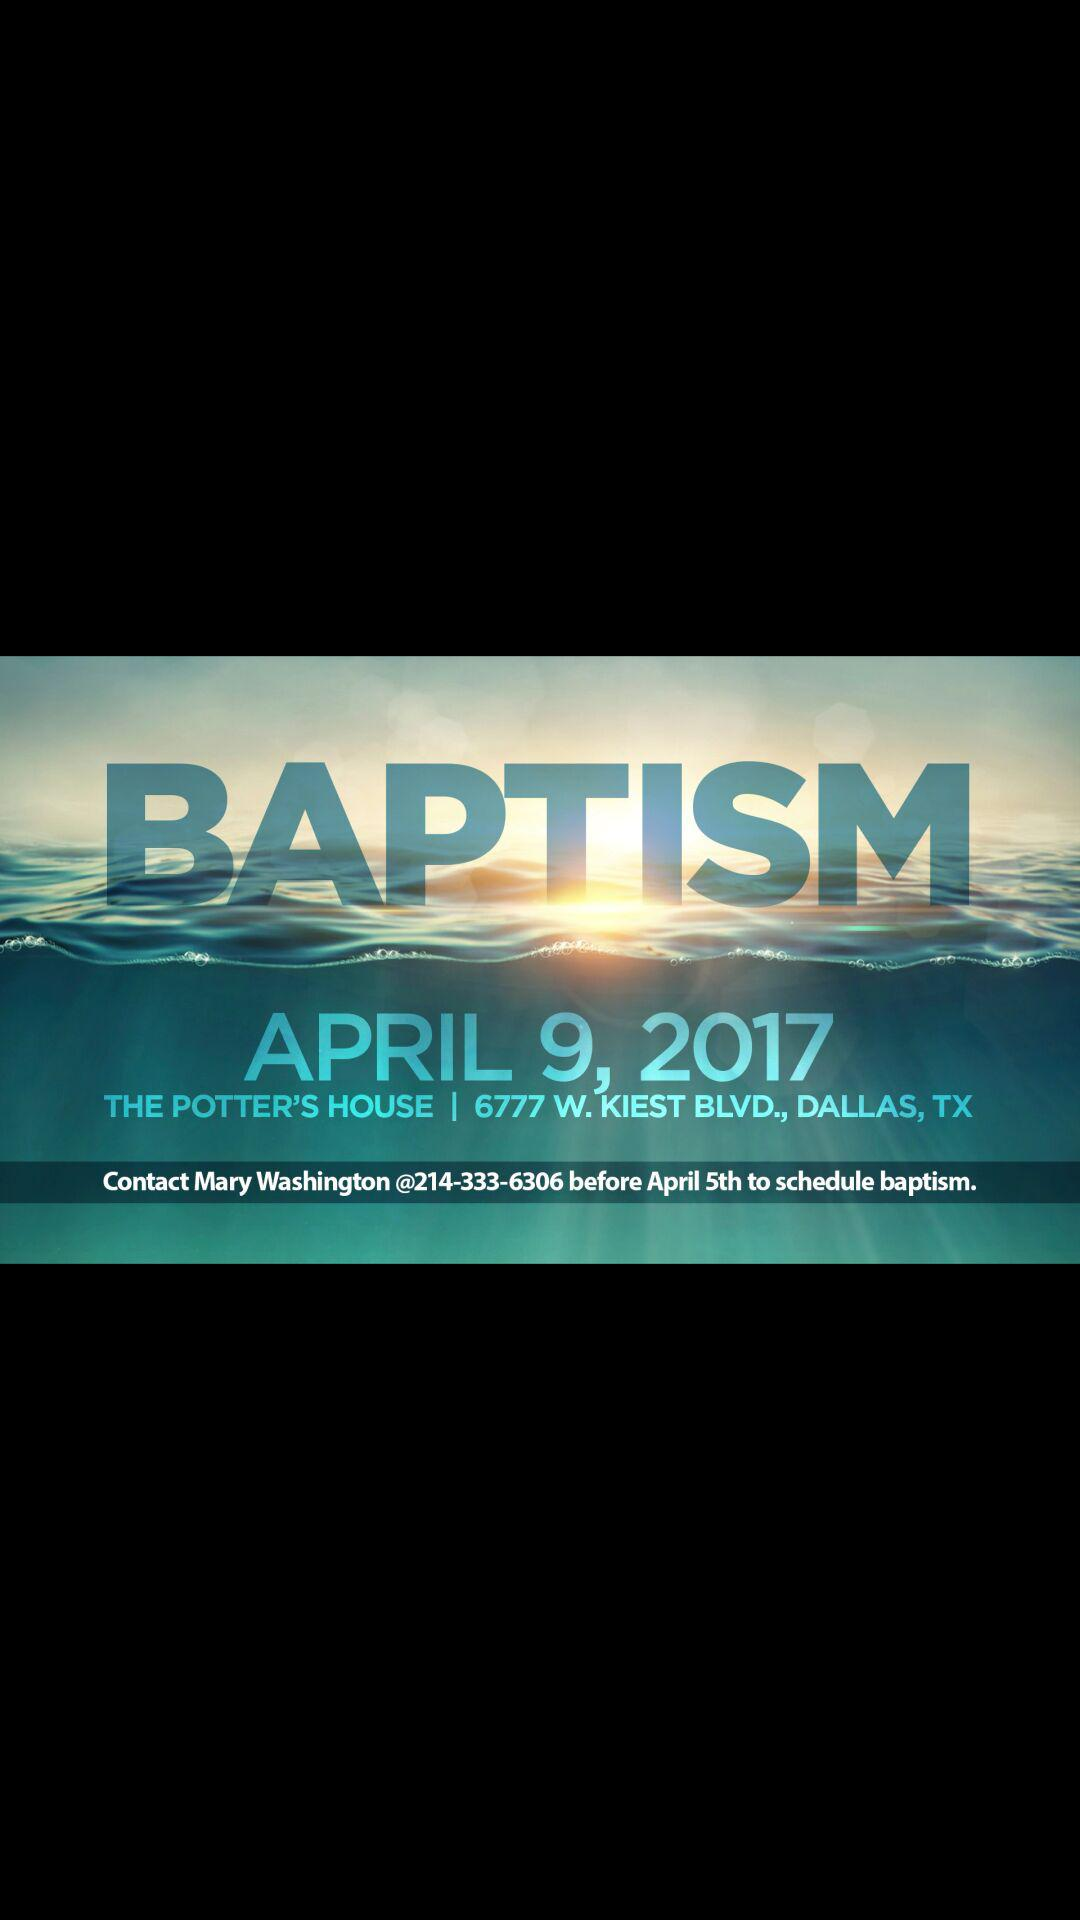How many days are there between the date of the baptism and the deadline for scheduling a baptism?
Answer the question using a single word or phrase. 4 